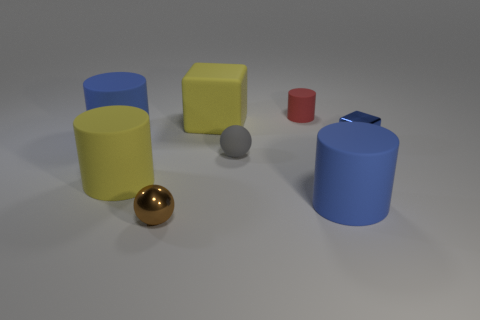What number of objects are blue matte things or tiny objects that are behind the small metal ball?
Provide a succinct answer. 5. There is a tiny object behind the large matte cube; is its shape the same as the rubber thing to the left of the yellow rubber cylinder?
Give a very brief answer. Yes. What number of objects are either big yellow matte things or small metal cubes?
Give a very brief answer. 3. Is there anything else that is the same material as the blue block?
Offer a terse response. Yes. Are there any large gray rubber cylinders?
Your response must be concise. No. Are the large cylinder right of the brown ball and the small cylinder made of the same material?
Offer a terse response. Yes. Is there a metallic thing of the same shape as the gray rubber object?
Offer a very short reply. Yes. Is the number of matte cylinders right of the gray object the same as the number of large cyan rubber cylinders?
Your response must be concise. No. There is a yellow thing that is behind the blue thing that is behind the blue block; what is it made of?
Keep it short and to the point. Rubber. There is a small gray thing; what shape is it?
Provide a succinct answer. Sphere. 